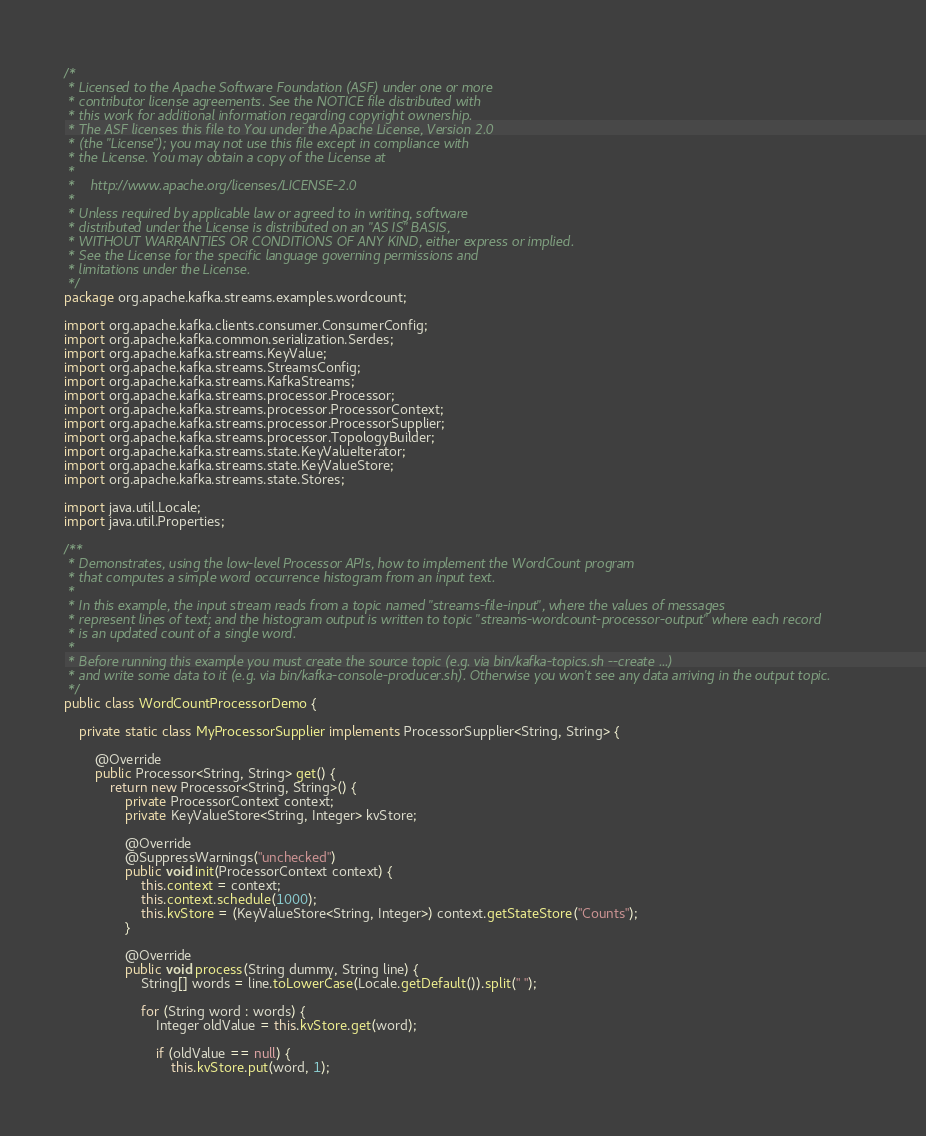Convert code to text. <code><loc_0><loc_0><loc_500><loc_500><_Java_>/*
 * Licensed to the Apache Software Foundation (ASF) under one or more
 * contributor license agreements. See the NOTICE file distributed with
 * this work for additional information regarding copyright ownership.
 * The ASF licenses this file to You under the Apache License, Version 2.0
 * (the "License"); you may not use this file except in compliance with
 * the License. You may obtain a copy of the License at
 *
 *    http://www.apache.org/licenses/LICENSE-2.0
 *
 * Unless required by applicable law or agreed to in writing, software
 * distributed under the License is distributed on an "AS IS" BASIS,
 * WITHOUT WARRANTIES OR CONDITIONS OF ANY KIND, either express or implied.
 * See the License for the specific language governing permissions and
 * limitations under the License.
 */
package org.apache.kafka.streams.examples.wordcount;

import org.apache.kafka.clients.consumer.ConsumerConfig;
import org.apache.kafka.common.serialization.Serdes;
import org.apache.kafka.streams.KeyValue;
import org.apache.kafka.streams.StreamsConfig;
import org.apache.kafka.streams.KafkaStreams;
import org.apache.kafka.streams.processor.Processor;
import org.apache.kafka.streams.processor.ProcessorContext;
import org.apache.kafka.streams.processor.ProcessorSupplier;
import org.apache.kafka.streams.processor.TopologyBuilder;
import org.apache.kafka.streams.state.KeyValueIterator;
import org.apache.kafka.streams.state.KeyValueStore;
import org.apache.kafka.streams.state.Stores;

import java.util.Locale;
import java.util.Properties;

/**
 * Demonstrates, using the low-level Processor APIs, how to implement the WordCount program
 * that computes a simple word occurrence histogram from an input text.
 *
 * In this example, the input stream reads from a topic named "streams-file-input", where the values of messages
 * represent lines of text; and the histogram output is written to topic "streams-wordcount-processor-output" where each record
 * is an updated count of a single word.
 *
 * Before running this example you must create the source topic (e.g. via bin/kafka-topics.sh --create ...)
 * and write some data to it (e.g. via bin/kafka-console-producer.sh). Otherwise you won't see any data arriving in the output topic.
 */
public class WordCountProcessorDemo {

    private static class MyProcessorSupplier implements ProcessorSupplier<String, String> {

        @Override
        public Processor<String, String> get() {
            return new Processor<String, String>() {
                private ProcessorContext context;
                private KeyValueStore<String, Integer> kvStore;

                @Override
                @SuppressWarnings("unchecked")
                public void init(ProcessorContext context) {
                    this.context = context;
                    this.context.schedule(1000);
                    this.kvStore = (KeyValueStore<String, Integer>) context.getStateStore("Counts");
                }

                @Override
                public void process(String dummy, String line) {
                    String[] words = line.toLowerCase(Locale.getDefault()).split(" ");

                    for (String word : words) {
                        Integer oldValue = this.kvStore.get(word);

                        if (oldValue == null) {
                            this.kvStore.put(word, 1);</code> 